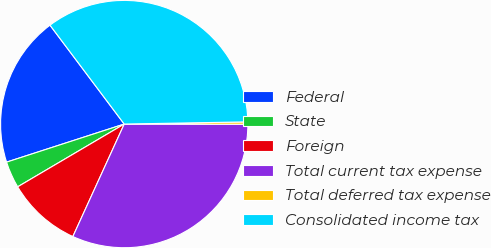Convert chart. <chart><loc_0><loc_0><loc_500><loc_500><pie_chart><fcel>Federal<fcel>State<fcel>Foreign<fcel>Total current tax expense<fcel>Total deferred tax expense<fcel>Consolidated income tax<nl><fcel>19.73%<fcel>3.49%<fcel>9.71%<fcel>31.79%<fcel>0.31%<fcel>34.96%<nl></chart> 